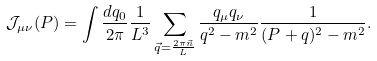<formula> <loc_0><loc_0><loc_500><loc_500>\mathcal { J } _ { \mu \nu } ( P ) = \int \frac { d q _ { 0 } } { 2 \pi } \frac { 1 } { L ^ { 3 } } \sum _ { \vec { q } = \frac { 2 \pi \vec { n } } { L } } \frac { q _ { \mu } q _ { \nu } } { q ^ { 2 } - m ^ { 2 } } \frac { 1 } { ( P + q ) ^ { 2 } - m ^ { 2 } } .</formula> 